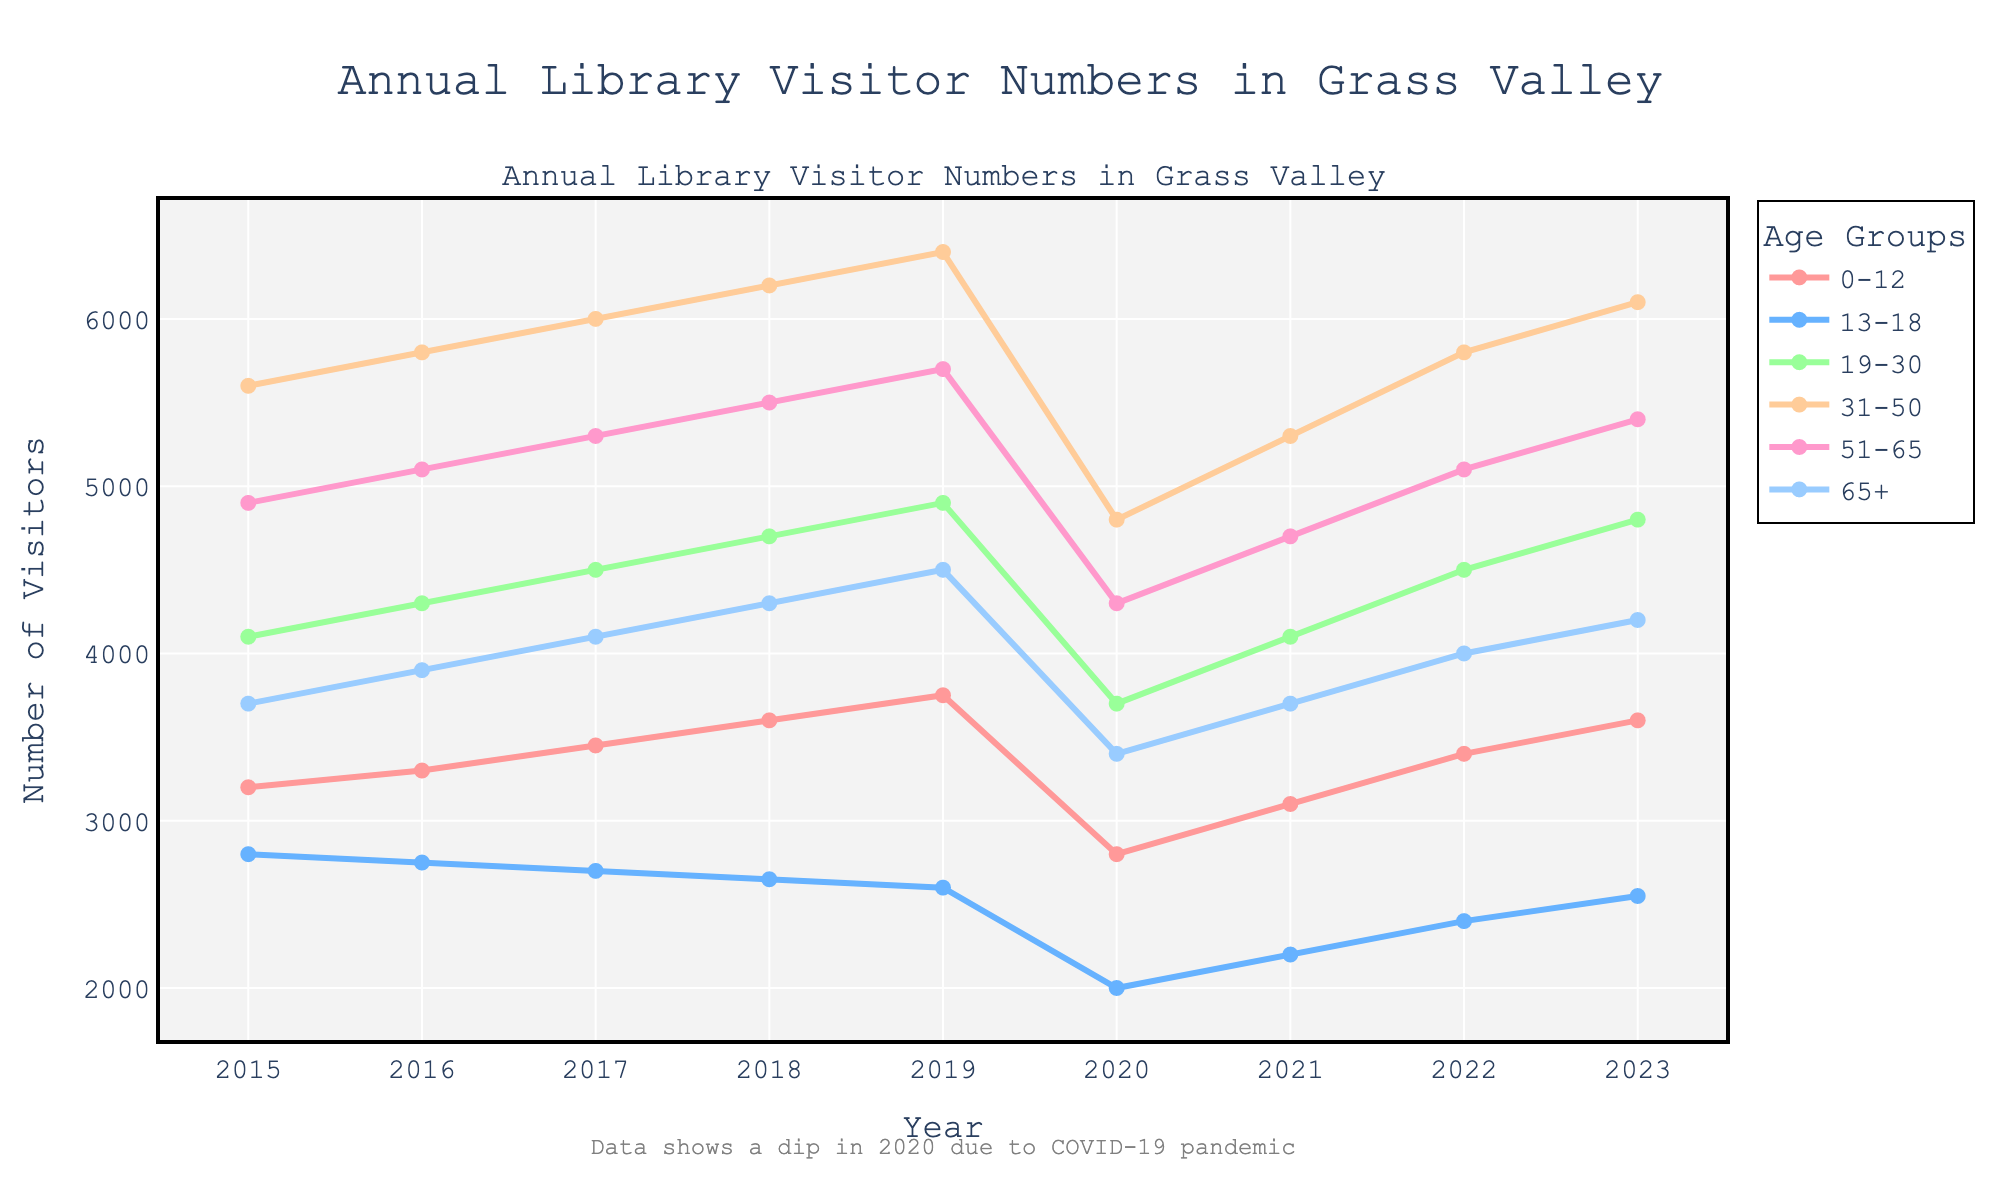What trend is observed in the year 2020 across all age groups? All age groups show a noticeable dip in visitor numbers in 2020 compared to the previous years.
Answer: Dip in 2020 Which age group had the highest number of visitors in 2023? By looking at the 2023 data, the age group 31-50 has the highest number of visitors at 6100.
Answer: 31-50 How does the trend of visitors aged 13-18 compare to visitors aged 51-65 from 2015 to 2023? From 2015 to 2023, visitors aged 13-18 show a decline, especially pronounced after 2015, while visitors aged 51-65 generally show an increasing trend despite the dip in 2020.
Answer: 13-18 declines, 51-65 increases What is the total number of visitors for all age groups in 2019? Sum the number of visitors across all age groups for 2019: 3750 (0-12) + 2600 (13-18) + 4900 (19-30) + 6400 (31-50) + 5700 (51-65) + 4500 (65+) = 27850.
Answer: 27850 What was the percentage increase in visitors aged 19-30 from 2020 to 2021? Calculate the percentage increase: ((4100 - 3700) / 3700) * 100 = (400 / 3700) * 100 ≈ 10.81%.
Answer: ~10.81% Which age group had the steepest recovery from 2020 to 2021? By observing the recovery from the dip in 2020 to 2021, the age group 31-50 had the most significant increase from 4800 to 5300.
Answer: 31-50 What was the difference in visitor numbers aged 0-12 between the highest and lowest years shown? The highest visitor numbers for 0-12 were in 2019 (3750), and the lowest were in 2020 (2800). The difference is 3750 - 2800 = 950.
Answer: 950 